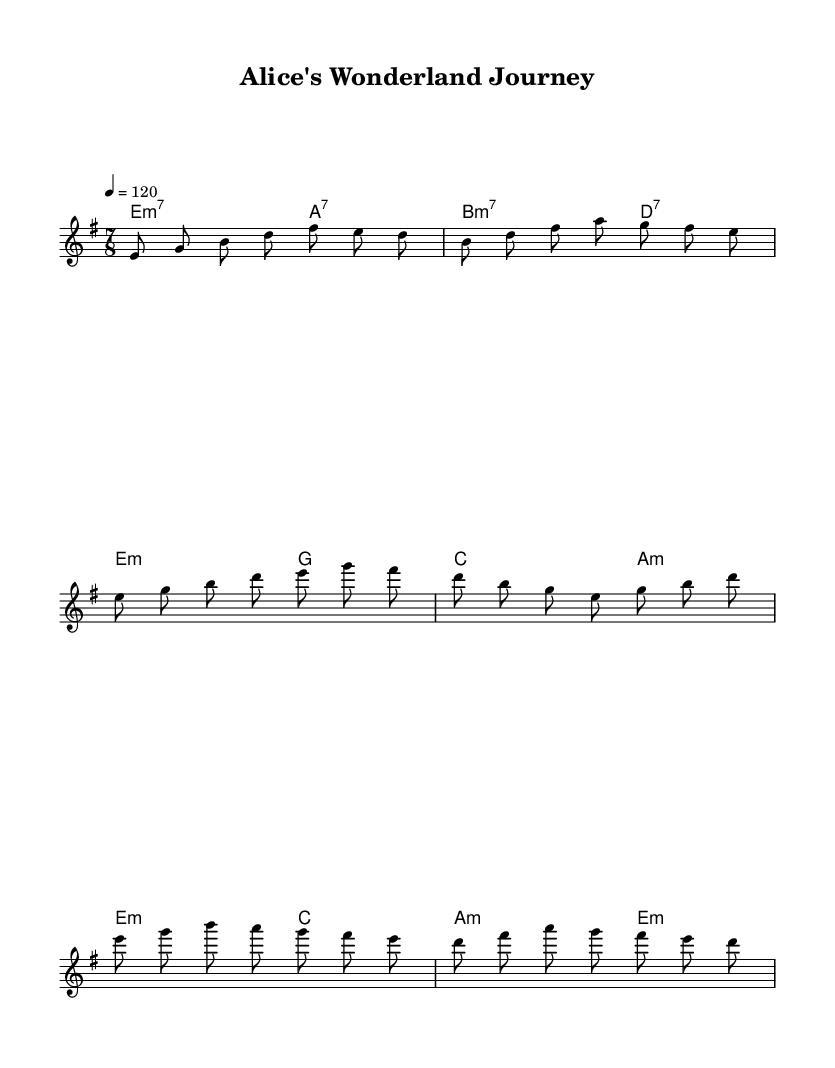What is the key signature of this music? The key signature is indicated as E minor, which has one sharp (F#).
Answer: E minor What is the time signature of this music? The time signature is given as 7/8, meaning there are seven beats in each measure, and the eighth note gets one beat.
Answer: 7/8 What is the tempo marking for this piece? The tempo marking states that the piece should be played at a speed of 120 beats per minute, indicated by the notation "4 = 120."
Answer: 120 What is the chord for the introduction section? The introduction features the chords E minor 7 and A dominant 7, which are denoted as E2:m7 and A4.:7 respectively.
Answer: E minor 7, A dominant 7 Which section of the composition has a melodic phrase that starts on B? The verse section begins with the melodic phrase that starts on the note B, which can be identified by the first note of that section in the melody line.
Answer: Verse What notes make up the chorus melody's first measure? The first measure of the chorus includes the notes E, G, B, and A, as stated in the melody part of the sheet music.
Answer: E, G, B, A What is the overall musical structure of the composition? The structure of the composition consists of an intro, followed by a verse, and then a chorus, as indicated by the layout of the sections in the sheet music.
Answer: Intro, Verse, Chorus 